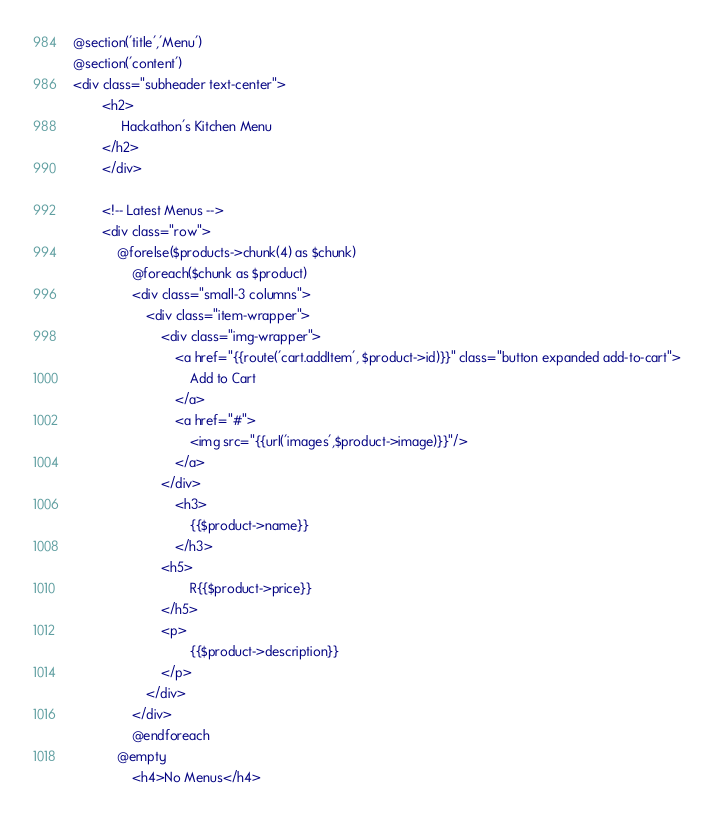<code> <loc_0><loc_0><loc_500><loc_500><_PHP_>@section('title','Menu')
@section('content')
<div class="subheader text-center">
        <h2>
             Hackathon's Kitchen Menu
        </h2>
        </div>
       
        <!-- Latest Menus -->
        <div class="row">
            @forelse($products->chunk(4) as $chunk)
                @foreach($chunk as $product) 
                <div class="small-3 columns">
                    <div class="item-wrapper">
                        <div class="img-wrapper">
                            <a href="{{route('cart.addItem', $product->id)}}" class="button expanded add-to-cart">
                                Add to Cart
                            </a>
                            <a href="#">
                                <img src="{{url('images',$product->image)}}"/>
                            </a>
                        </div>
                            <h3>
                                {{$product->name}}
                            </h3>
                        <h5>
                                R{{$product->price}}
                        </h5>
                        <p>
                                {{$product->description}}
                        </p>
                    </div>
                </div>
                @endforeach
            @empty
                <h4>No Menus</h4></code> 